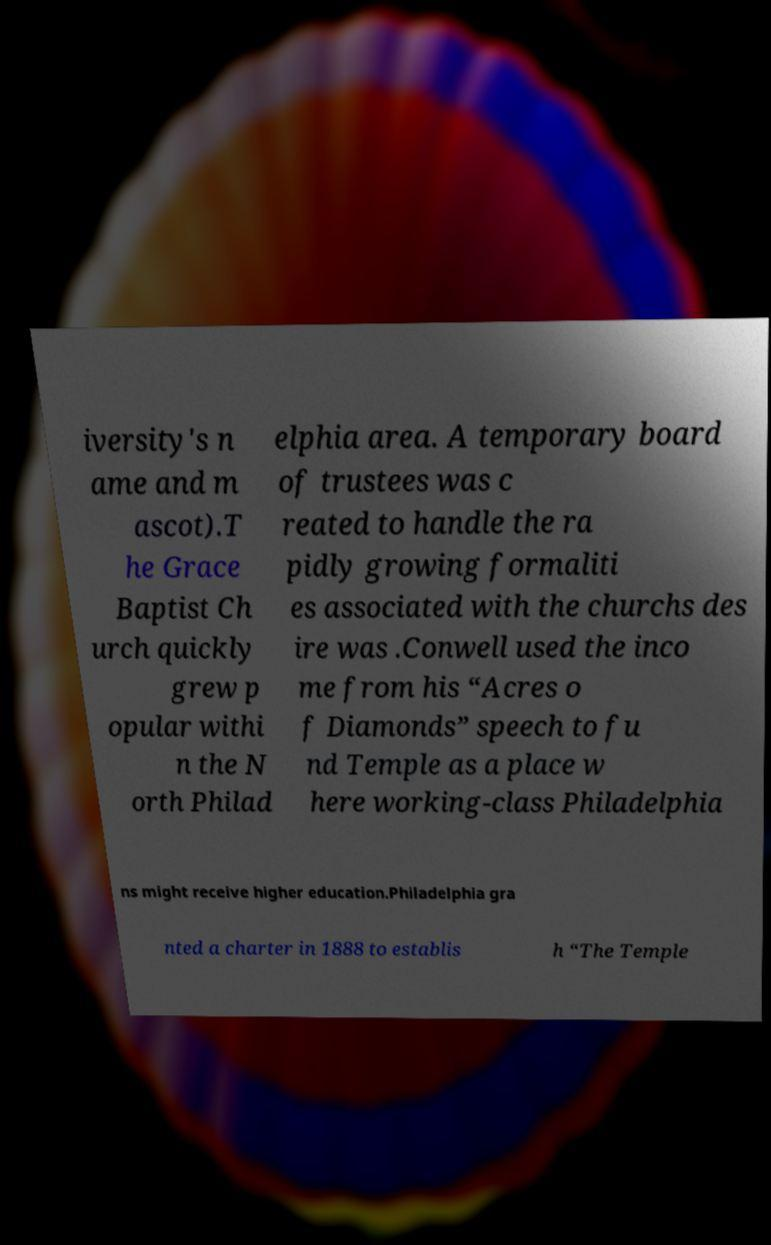Could you extract and type out the text from this image? iversity's n ame and m ascot).T he Grace Baptist Ch urch quickly grew p opular withi n the N orth Philad elphia area. A temporary board of trustees was c reated to handle the ra pidly growing formaliti es associated with the churchs des ire was .Conwell used the inco me from his “Acres o f Diamonds” speech to fu nd Temple as a place w here working-class Philadelphia ns might receive higher education.Philadelphia gra nted a charter in 1888 to establis h “The Temple 